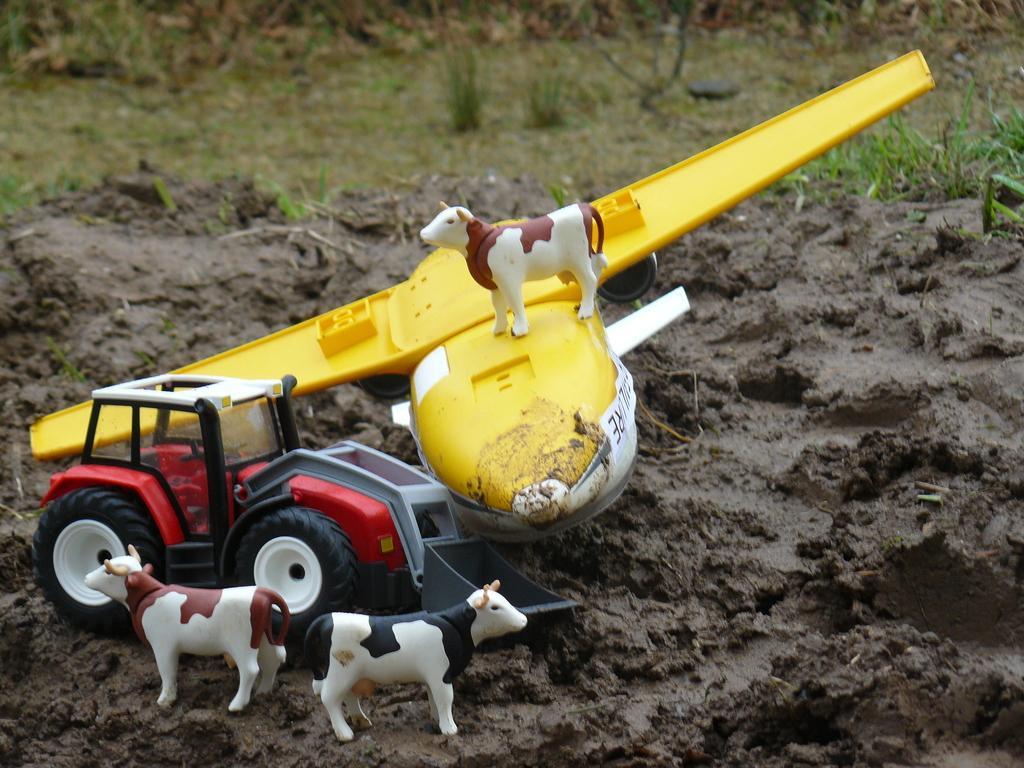Could you give a brief overview of what you see in this image? In this image there are cows, tractor on the surface of the soil. At the background there is a grass on the surface. 